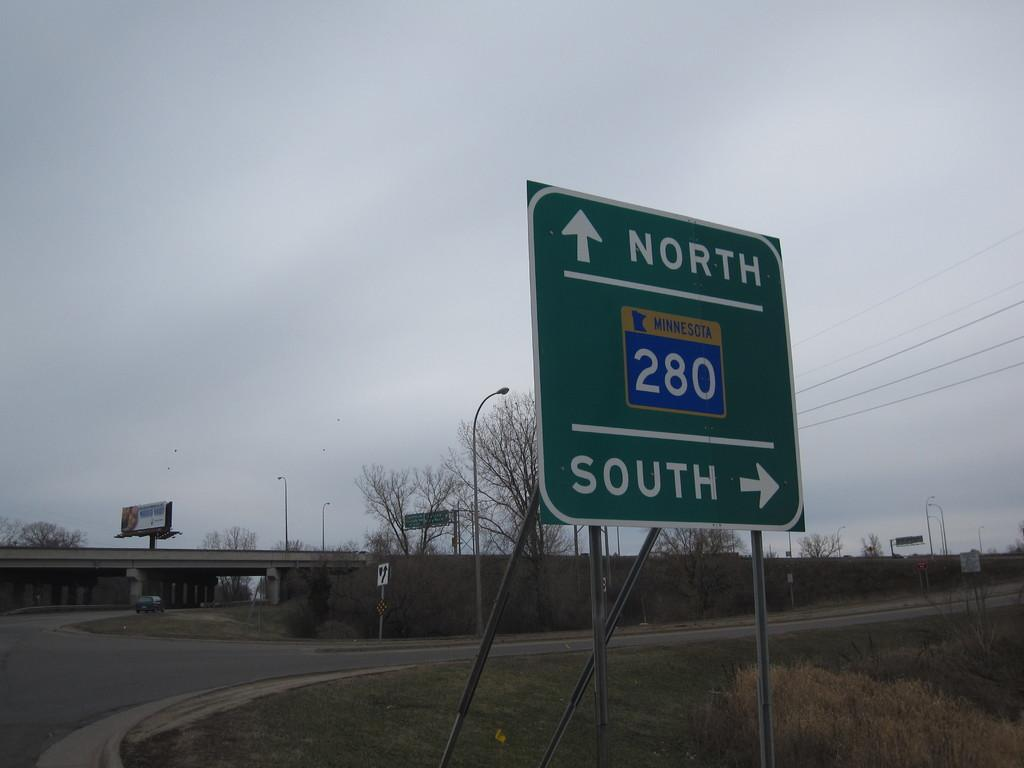Provide a one-sentence caption for the provided image. A street sign for Minnesota 280 directing them to onramps that are north and southbound. 